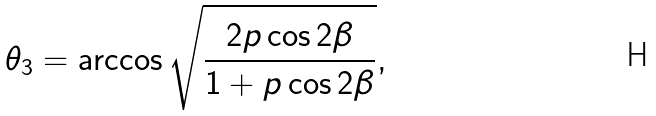<formula> <loc_0><loc_0><loc_500><loc_500>\theta _ { 3 } = \arccos { \sqrt { \frac { 2 p \cos { 2 \beta } } { 1 + p \cos { 2 \beta } } } } ,</formula> 